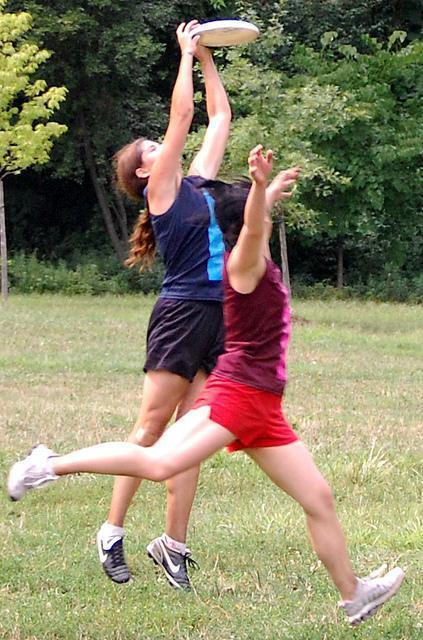How many people are there?
Give a very brief answer. 2. 